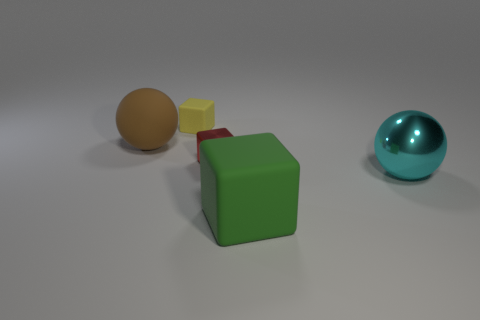Add 2 large green metallic things. How many objects exist? 7 Subtract all spheres. How many objects are left? 3 Add 1 tiny yellow objects. How many tiny yellow objects are left? 2 Add 2 cyan objects. How many cyan objects exist? 3 Subtract 1 cyan spheres. How many objects are left? 4 Subtract all brown rubber cylinders. Subtract all green matte things. How many objects are left? 4 